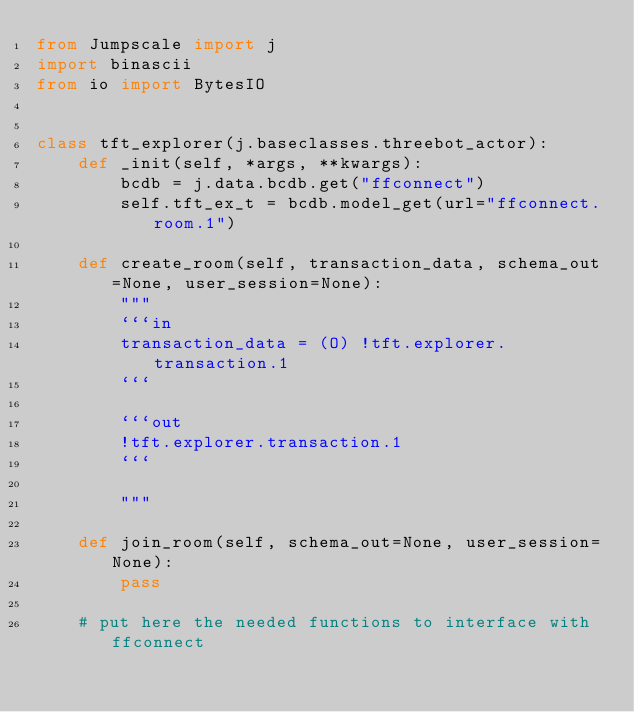Convert code to text. <code><loc_0><loc_0><loc_500><loc_500><_Python_>from Jumpscale import j
import binascii
from io import BytesIO


class tft_explorer(j.baseclasses.threebot_actor):
    def _init(self, *args, **kwargs):
        bcdb = j.data.bcdb.get("ffconnect")
        self.tft_ex_t = bcdb.model_get(url="ffconnect.room.1")

    def create_room(self, transaction_data, schema_out=None, user_session=None):
        """
        ```in
        transaction_data = (O) !tft.explorer.transaction.1
        ```

        ```out
        !tft.explorer.transaction.1
        ```

        """

    def join_room(self, schema_out=None, user_session=None):
        pass

    # put here the needed functions to interface with ffconnect
</code> 